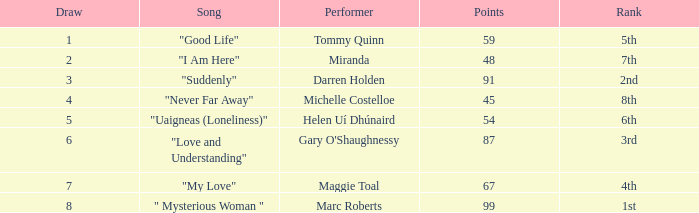What is the standard number of points for a song ranking 2nd with a draw more than 3? None. 